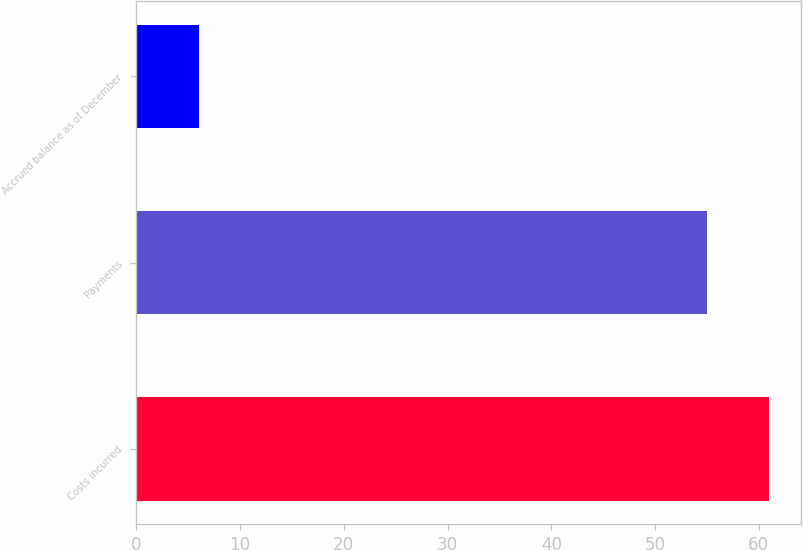Convert chart to OTSL. <chart><loc_0><loc_0><loc_500><loc_500><bar_chart><fcel>Costs incurred<fcel>Payments<fcel>Accrued balance as of December<nl><fcel>61<fcel>55<fcel>6<nl></chart> 